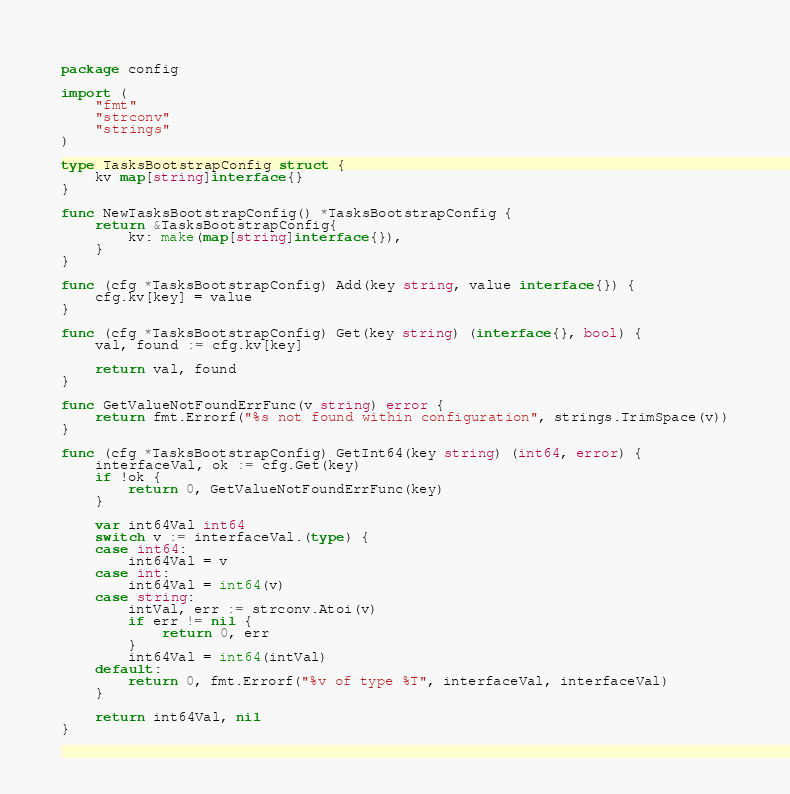<code> <loc_0><loc_0><loc_500><loc_500><_Go_>package config

import (
	"fmt"
	"strconv"
	"strings"
)

type TasksBootstrapConfig struct {
	kv map[string]interface{}
}

func NewTasksBootstrapConfig() *TasksBootstrapConfig {
	return &TasksBootstrapConfig{
		kv: make(map[string]interface{}),
	}
}

func (cfg *TasksBootstrapConfig) Add(key string, value interface{}) {
	cfg.kv[key] = value
}

func (cfg *TasksBootstrapConfig) Get(key string) (interface{}, bool) {
	val, found := cfg.kv[key]

	return val, found
}

func GetValueNotFoundErrFunc(v string) error {
	return fmt.Errorf("%s not found within configuration", strings.TrimSpace(v))
}

func (cfg *TasksBootstrapConfig) GetInt64(key string) (int64, error) {
	interfaceVal, ok := cfg.Get(key)
	if !ok {
		return 0, GetValueNotFoundErrFunc(key)
	}

	var int64Val int64
	switch v := interfaceVal.(type) {
	case int64:
		int64Val = v
	case int:
		int64Val = int64(v)
	case string:
		intVal, err := strconv.Atoi(v)
		if err != nil {
			return 0, err
		}
		int64Val = int64(intVal)
	default:
		return 0, fmt.Errorf("%v of type %T", interfaceVal, interfaceVal)
	}

	return int64Val, nil
}
</code> 